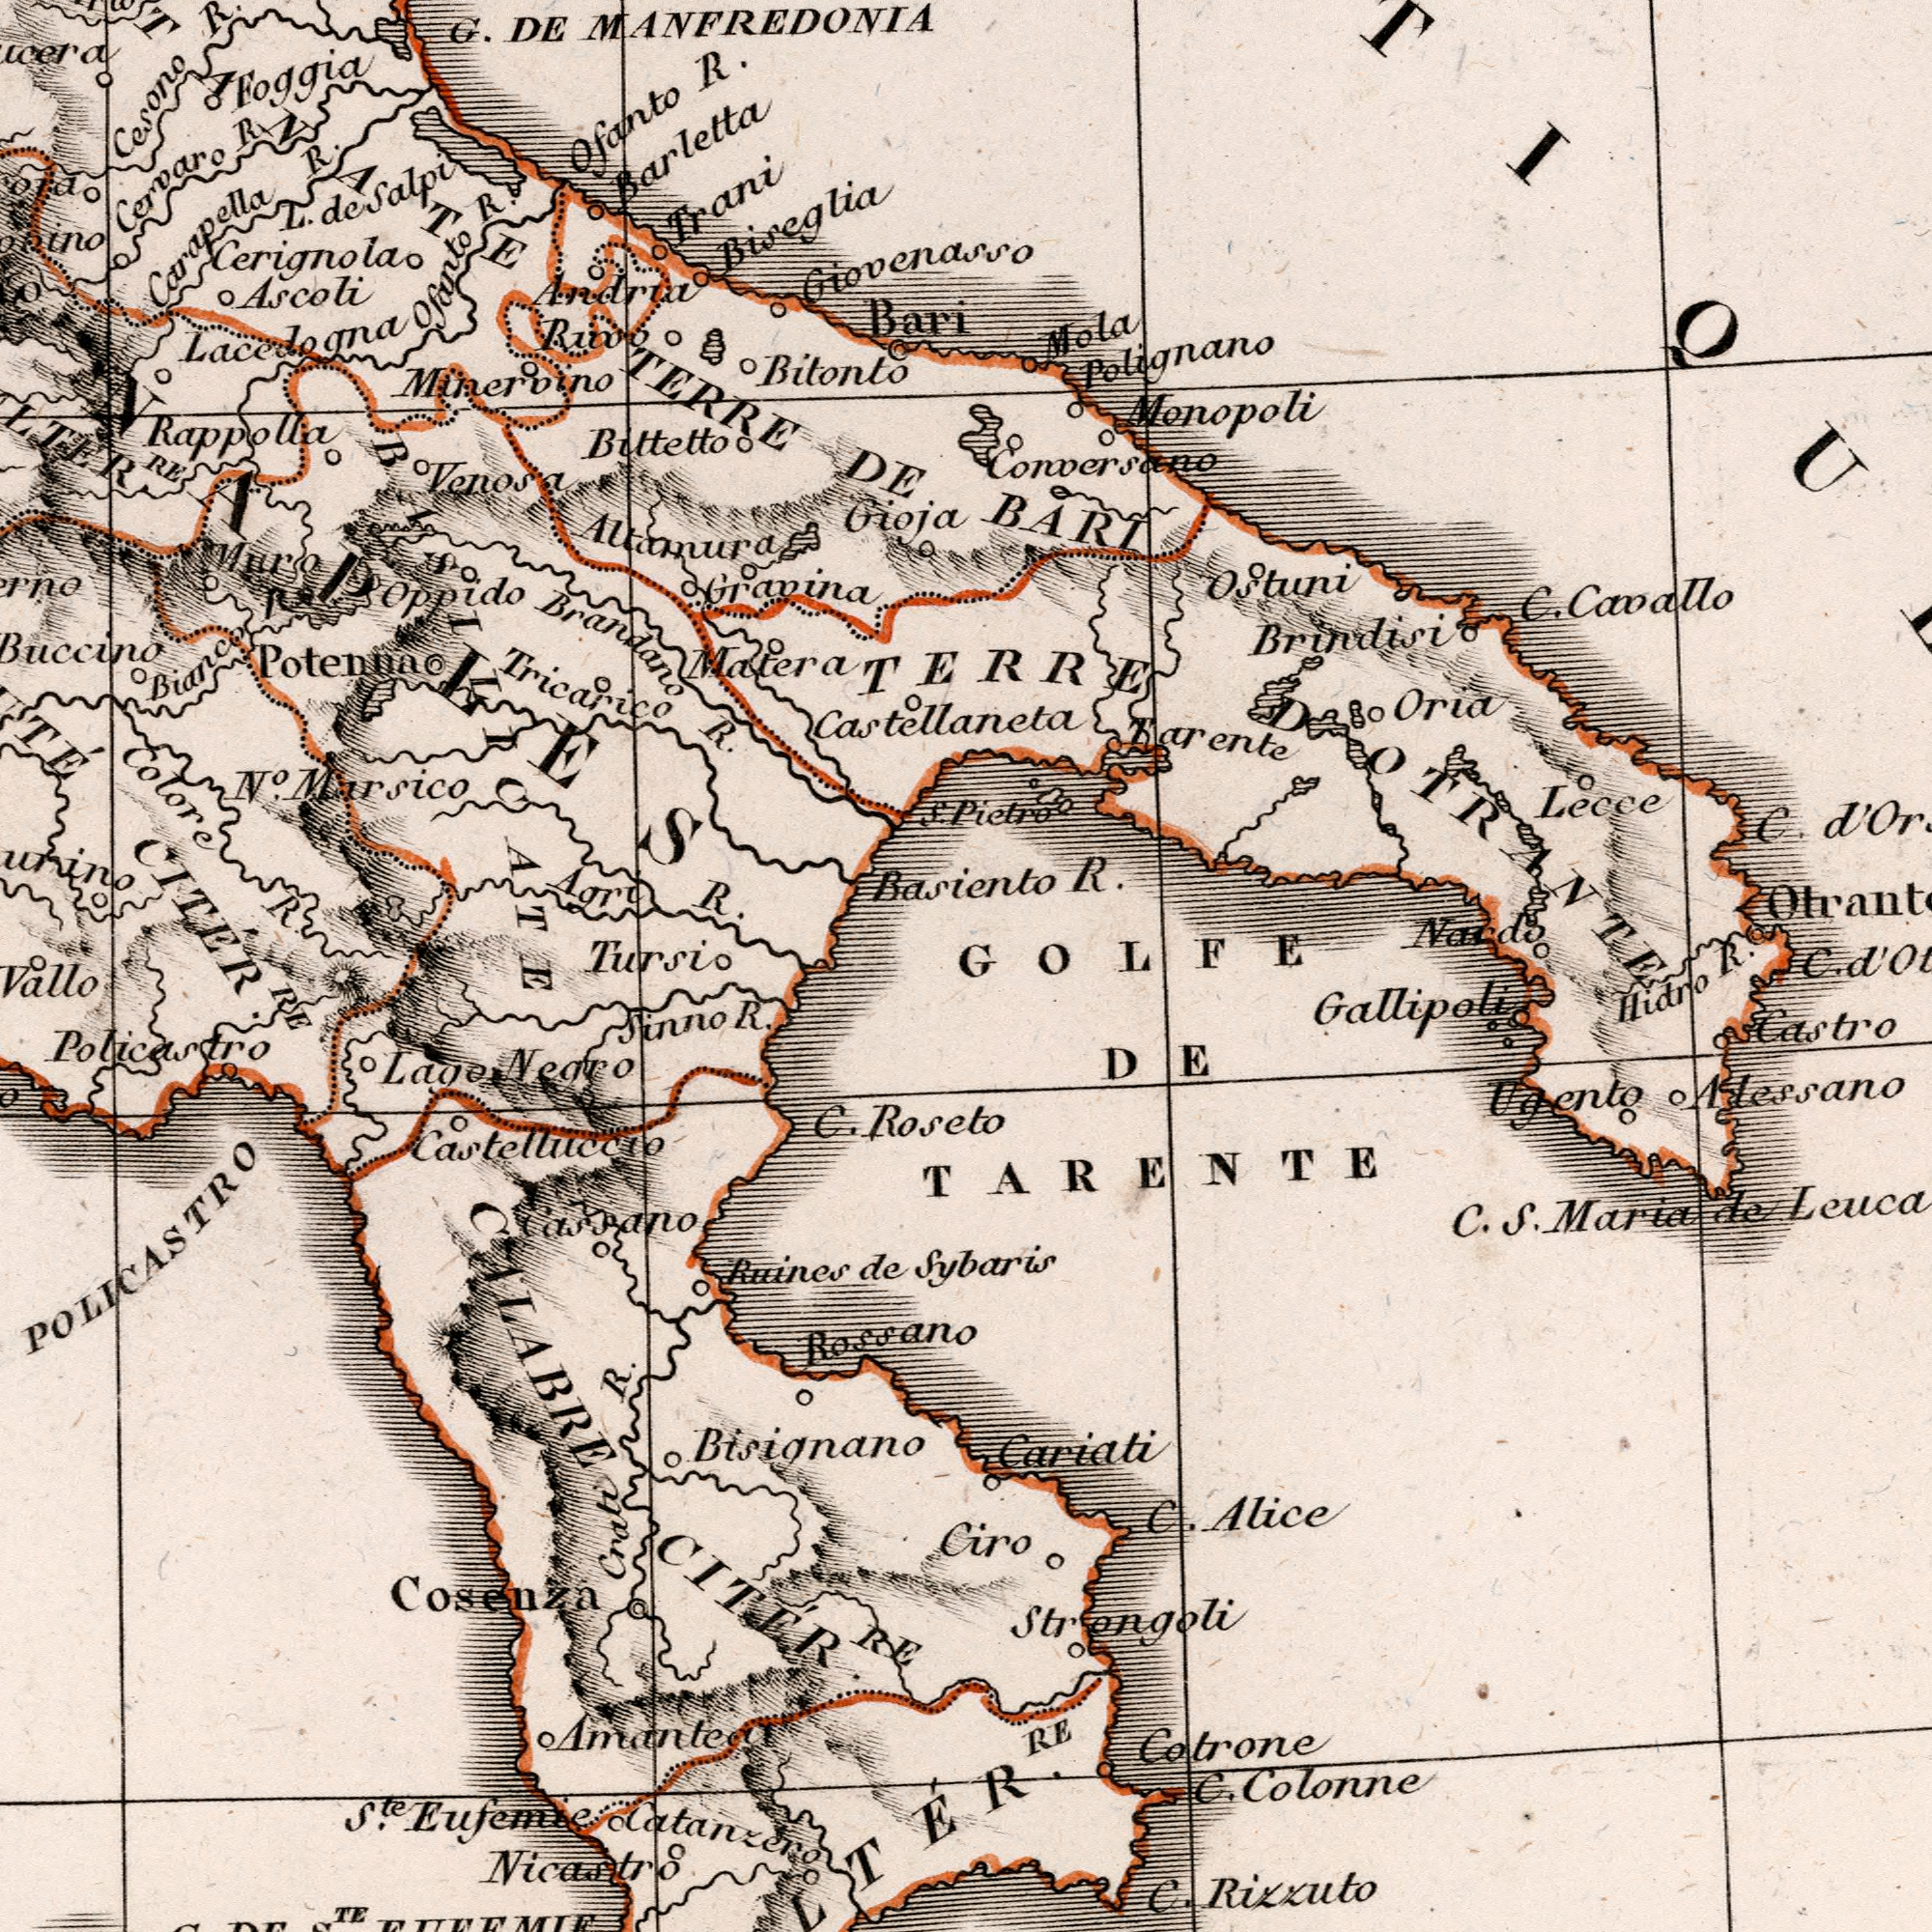What text appears in the top-right area of the image? BARI Basiento R. Pielro Monopoli Tarente OStuni Nardo C. Cavallo Lecce Brindisi C. Oria Conoersano Mola Polignano GOLFE TERRE D OTRANTE R. What text is visible in the lower-left corner? Cosenza Ruines de Lago Negro Sinno R. Crati R. RE Nicastro C. Roseto CALABRE CITÉR RE Policastro Cassano Amantea Ste. Eufemie Catanzero Castelluccio TE Bisignano POLICASTRO Rossano What text can you see in the bottom-right section? DE TARENTE Hidro Sybaris RE Cariati C. Colonne Cotrone C. Alice C. Rizzuto Castro Ugento C. S. Maria de Leuca Alessano Ciro Gallipoli Strongoli C. What text can you see in the top-left section? CITÉR Buccino Minervino Bitonto G. DE MANFREDONIA Ruio Brandano R. Ascoli Agri R. Foggia Oppido Gioja TERRE DE Carapella R. Muro Altamura Barletta Giovenasso Bittetto Cerignola Tricarico Cesono R. Colore R. Ofanto R. Bianco Trani RE No. Mursico L. deSalpi Ofanto R. Granina Matera Venosa LaceJogna Cervaro R. Potenna Rappolla Tursio Bari Castellaneta S. Andrua Biseglia O NAPLES BASILICATE 